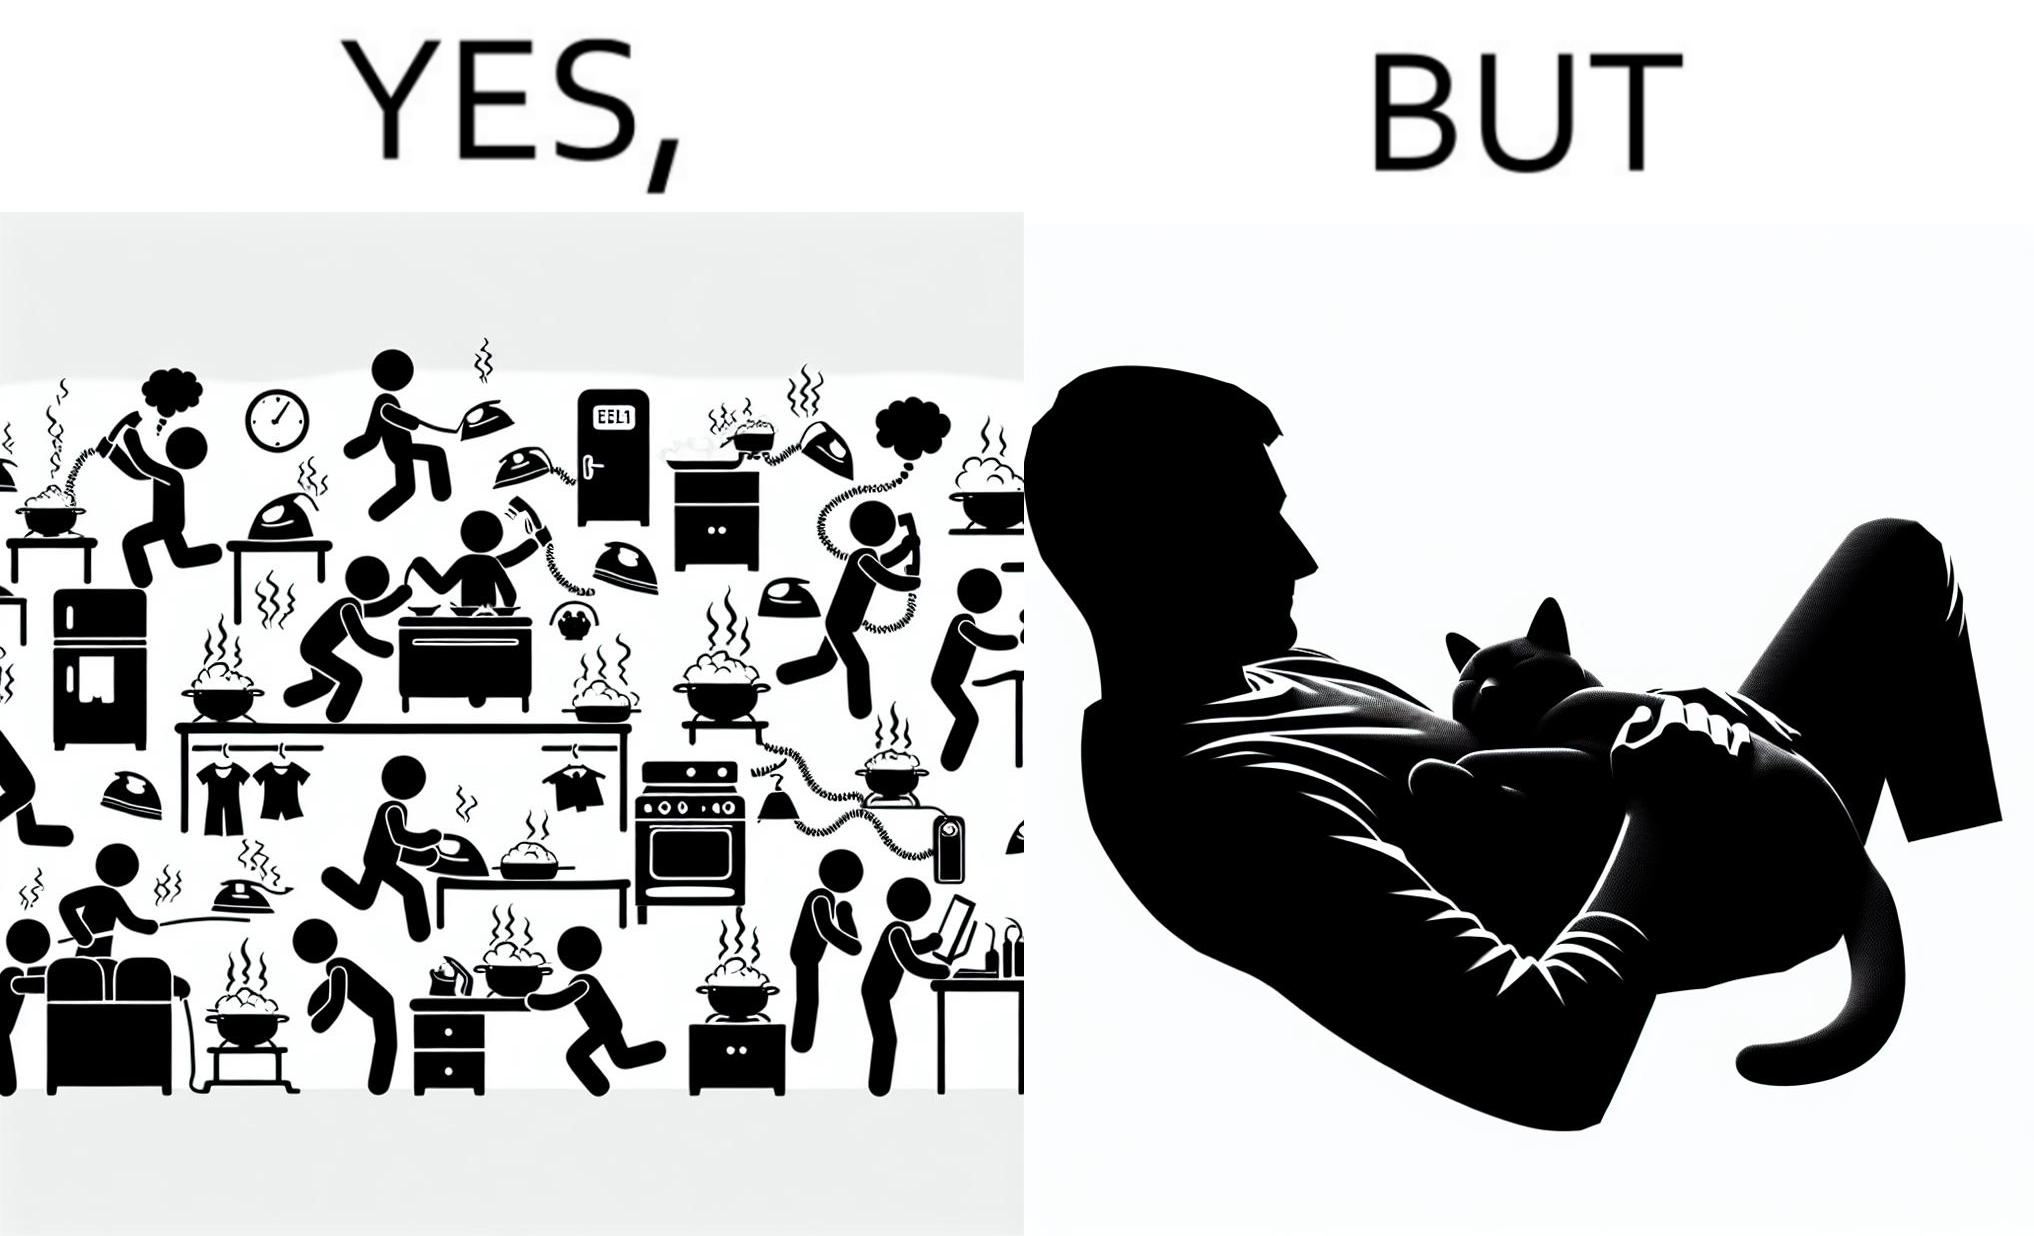What is the satirical meaning behind this image? the irony in this image is that people ignore all the chaos around them and get distracted by a cat. 